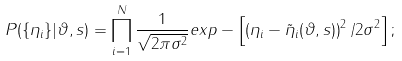<formula> <loc_0><loc_0><loc_500><loc_500>P ( \{ \eta _ { i } \} | \vartheta , s ) = \prod _ { i = 1 } ^ { N } \frac { 1 } { \sqrt { 2 \pi \sigma ^ { 2 } } } e x p - \left [ \left ( \eta _ { i } - \tilde { \eta } _ { i } ( \vartheta , s ) \right ) ^ { 2 } / 2 \sigma ^ { 2 } \right ] ;</formula> 